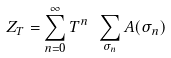Convert formula to latex. <formula><loc_0><loc_0><loc_500><loc_500>Z _ { T } = \sum _ { n = 0 } ^ { \infty } T ^ { n } \ \sum _ { \sigma _ { n } } A ( \sigma _ { n } )</formula> 